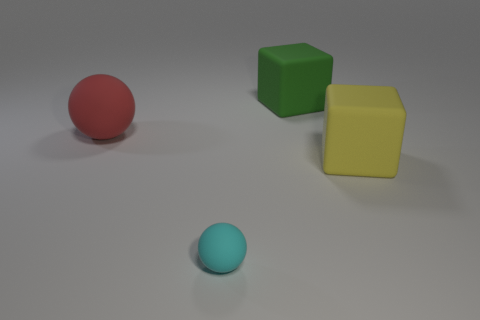Add 2 yellow matte cylinders. How many objects exist? 6 Add 3 blocks. How many blocks are left? 5 Add 4 large green cylinders. How many large green cylinders exist? 4 Subtract 1 yellow cubes. How many objects are left? 3 Subtract all spheres. Subtract all small balls. How many objects are left? 1 